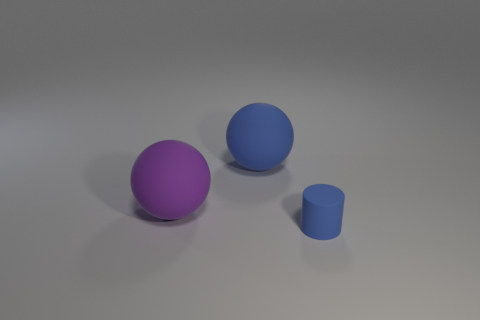Are there more tiny rubber cylinders behind the blue cylinder than purple rubber objects that are on the right side of the purple ball?
Keep it short and to the point. No. Is the blue thing that is behind the small blue cylinder made of the same material as the tiny blue object that is in front of the big blue rubber thing?
Offer a terse response. Yes. There is a blue rubber cylinder; are there any purple matte things to the left of it?
Provide a succinct answer. Yes. How many yellow things are either big matte objects or small rubber spheres?
Keep it short and to the point. 0. Does the blue sphere have the same material as the object that is in front of the purple sphere?
Ensure brevity in your answer.  Yes. What size is the other matte thing that is the same shape as the large blue matte object?
Your answer should be very brief. Large. What is the material of the small blue object?
Your answer should be very brief. Rubber. What material is the blue thing that is in front of the sphere in front of the blue thing that is behind the small matte object made of?
Give a very brief answer. Rubber. Is the size of the object that is right of the blue ball the same as the rubber object that is behind the purple ball?
Offer a very short reply. No. What number of metal things are cylinders or tiny balls?
Your answer should be very brief. 0. 